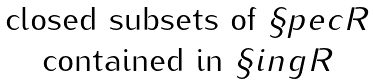Convert formula to latex. <formula><loc_0><loc_0><loc_500><loc_500>\begin{matrix} \text {closed subsets of } \S p e c R \\ \text {contained in } \S i n g R \end{matrix}</formula> 